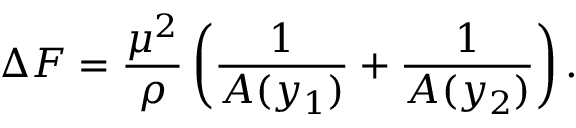<formula> <loc_0><loc_0><loc_500><loc_500>\Delta F = \frac { \mu ^ { 2 } } { \rho } \left ( \frac { 1 } { A ( y _ { 1 } ) } + \frac { 1 } { A ( y _ { 2 } ) } \right ) .</formula> 